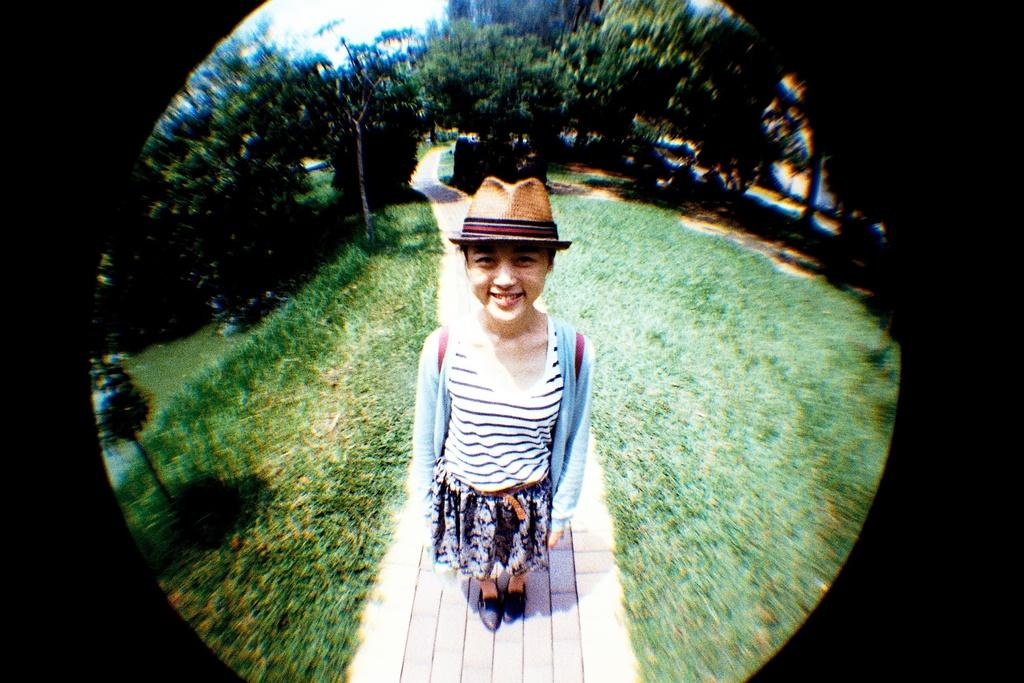Who is the main subject in the image? There is a girl in the center of the image. What is the girl wearing on her head? The girl is wearing a cap. What type of vegetation can be seen in the background of the image? There are trees in the background of the image. What is the ground surface like in the image? There is grass visible in the image. What type of nail is the girl using to whistle in the image? There is no nail or whistling activity present in the image. Who is the mother of the girl in the image? The provided facts do not mention the girl's mother or any other family members. 